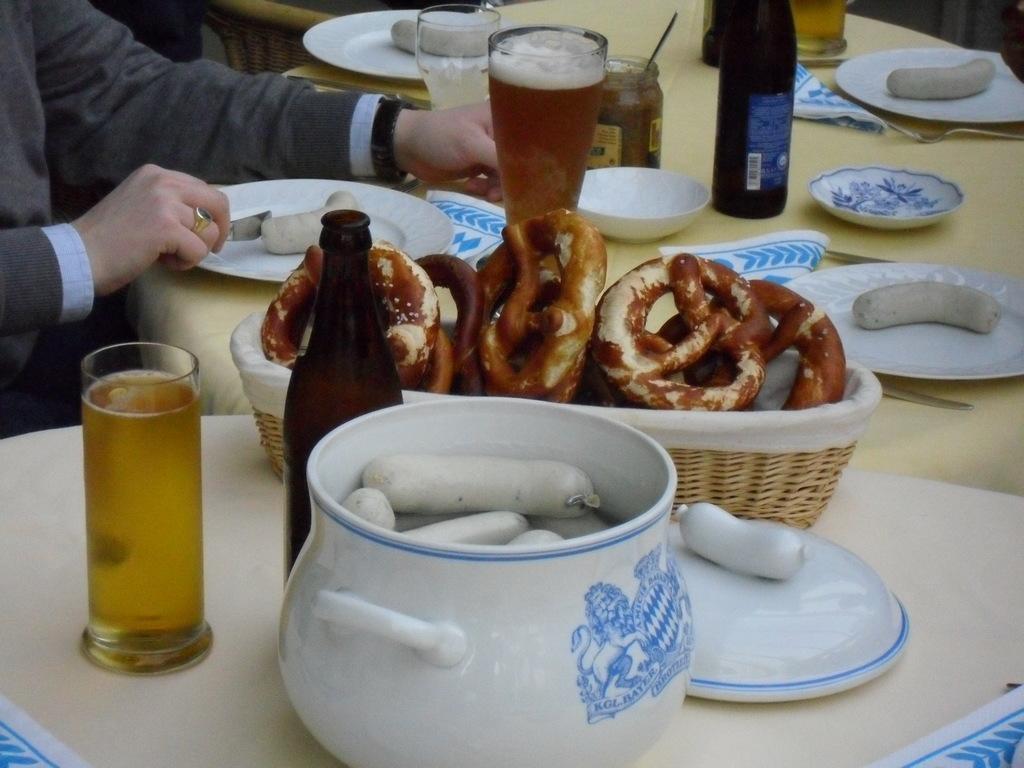Please provide a concise description of this image. In this image there are glasses, bottles and there are food items in a plate and a basket which was placed on the table. In front of the table there is a person sitting on the chair. 